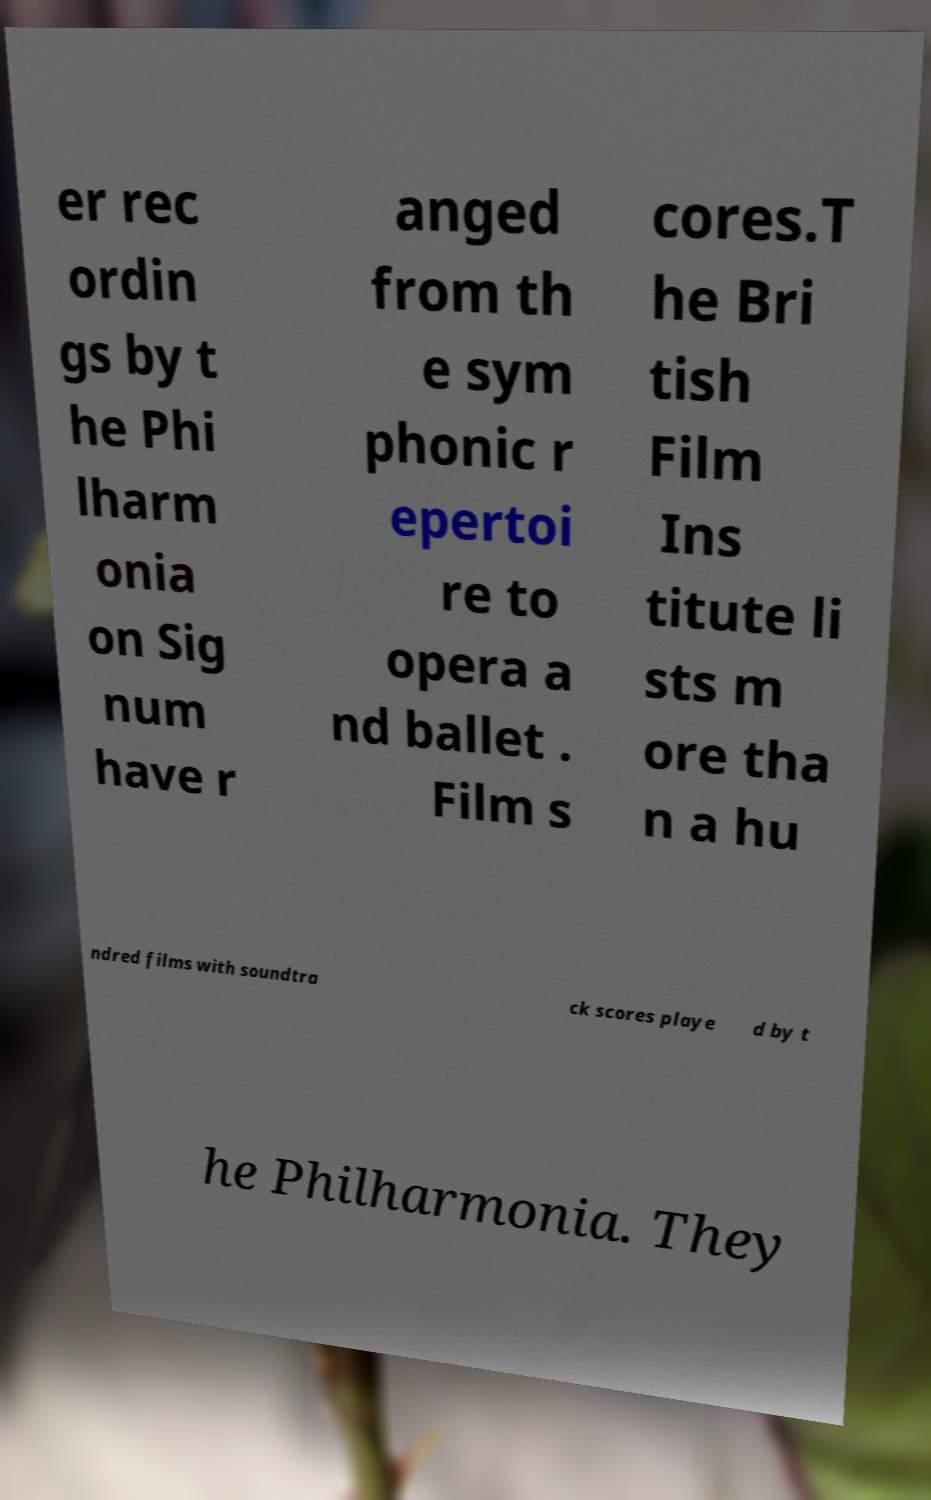Could you extract and type out the text from this image? er rec ordin gs by t he Phi lharm onia on Sig num have r anged from th e sym phonic r epertoi re to opera a nd ballet . Film s cores.T he Bri tish Film Ins titute li sts m ore tha n a hu ndred films with soundtra ck scores playe d by t he Philharmonia. They 